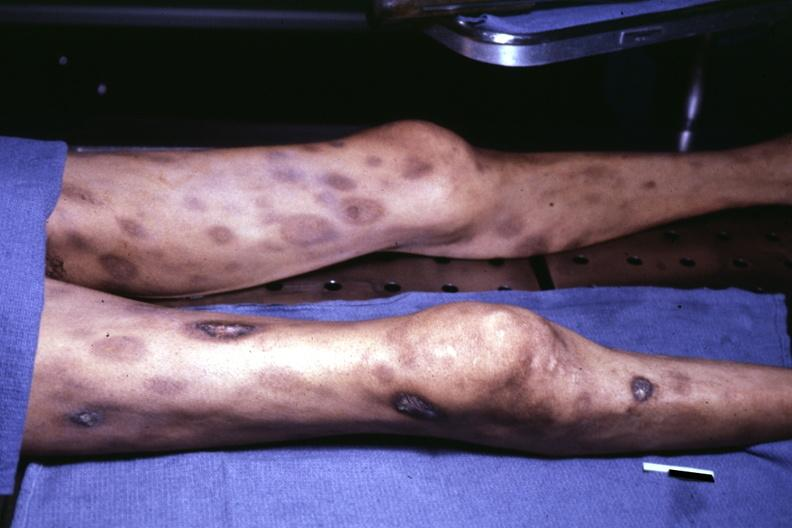where is this?
Answer the question using a single word or phrase. Skin 